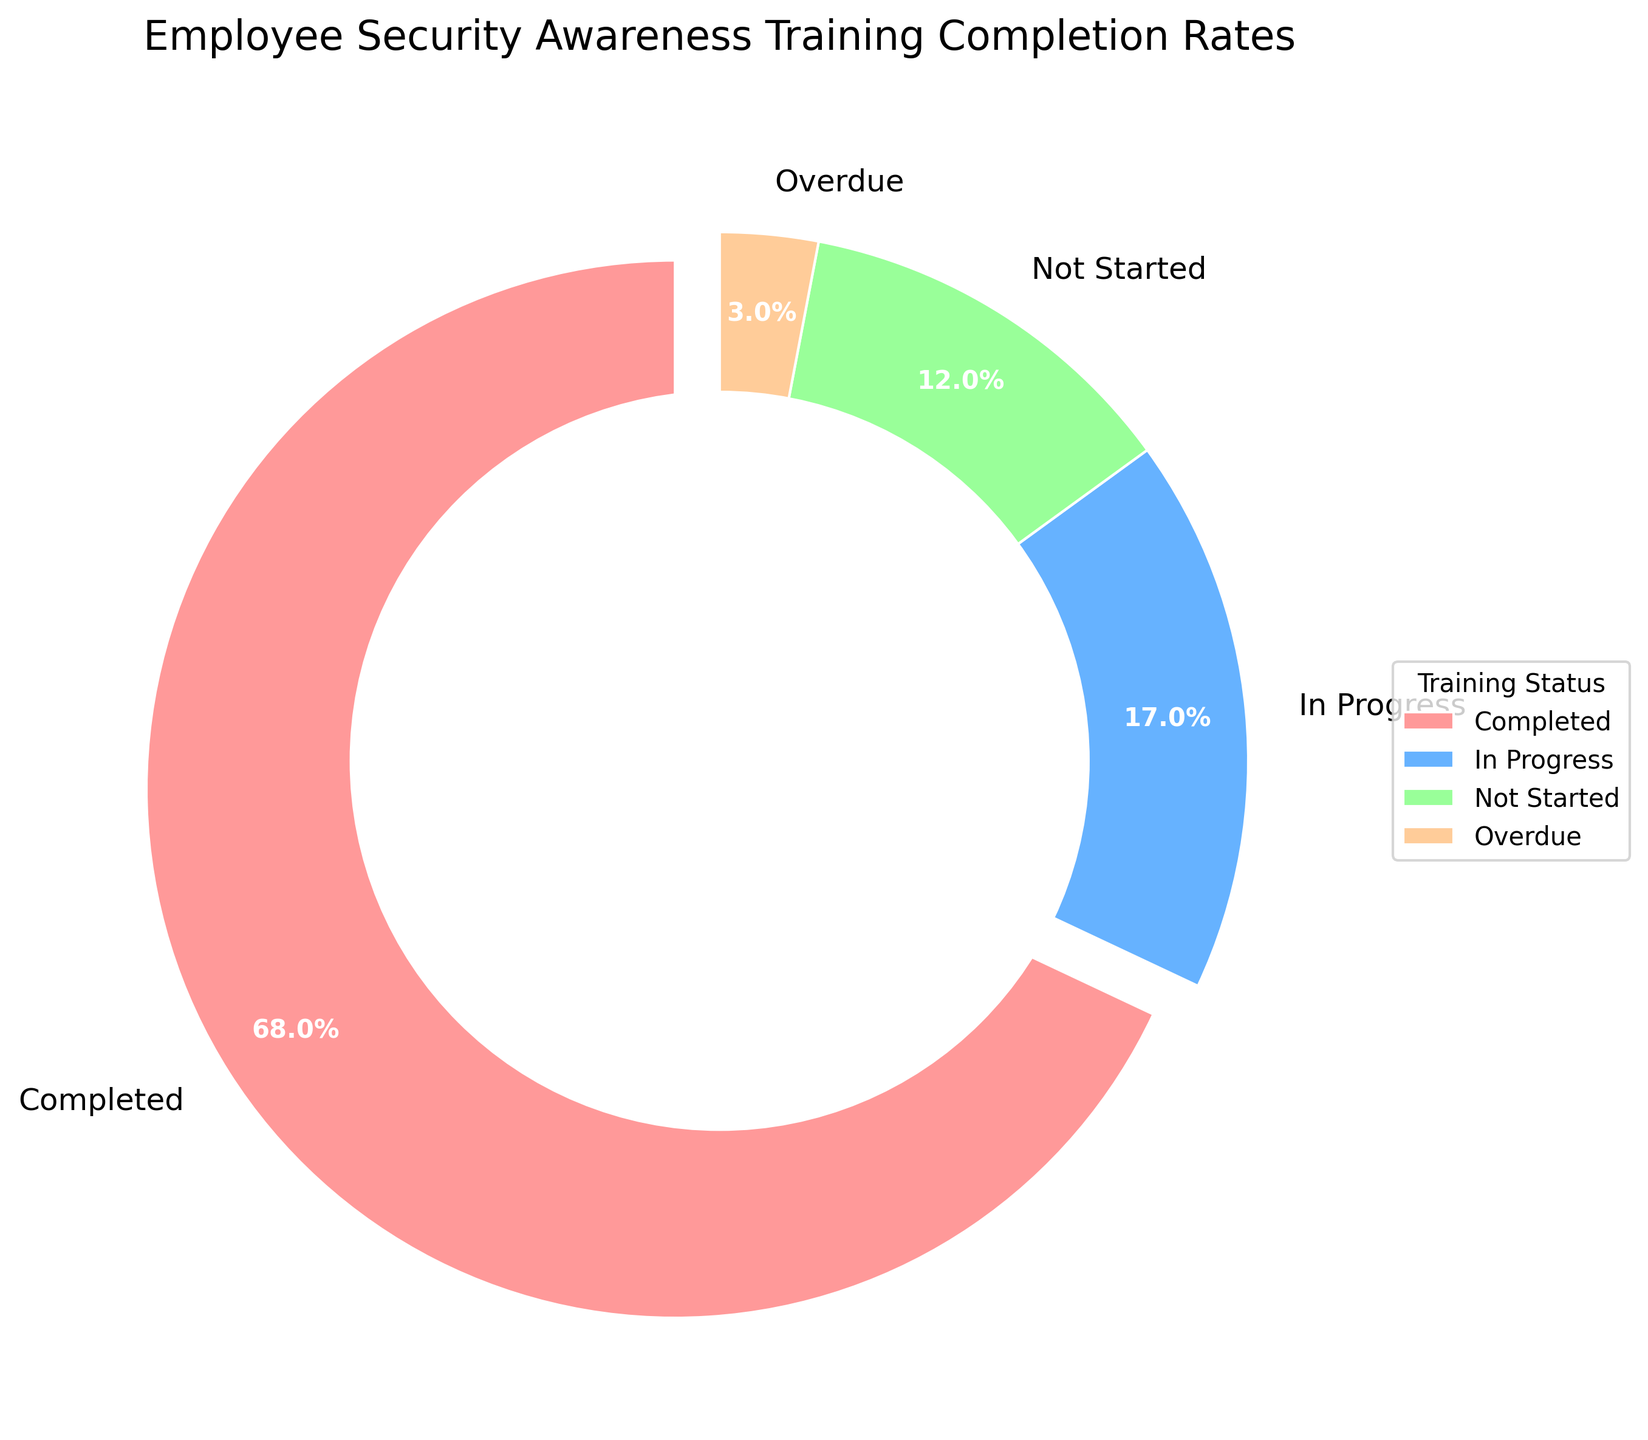What percentage of employees have completed the training? To find the percentage of employees who have completed the training, look at the "Completed" section of the pie chart. The chart indicates this percentage directly.
Answer: 68% Which training status has the smallest percentage? To determine the smallest percentage, visually compare the sizes of the slices in the pie chart. The slice labeled "Overdue" is the smallest.
Answer: Overdue What is the total percentage of employees who have either not started or are overdue in their training? Add the percentages for "Not Started" and "Overdue" together. That is 12% + 3% = 15%.
Answer: 15% Compare the percentage of employees who are "In Progress" with those who have "Not Started" the training. Compare the sizes of the slices labeled "In Progress" and "Not Started." The slice for "In Progress" is larger at 17%, while "Not Started" is 12%.
Answer: In Progress is larger What portion of the pie chart is represented by employees still involved in the training (both "In Progress" and "Not Started")? Add the percentages for "In Progress" and "Not Started". That is 17% + 12% = 29%.
Answer: 29% Which color represents the employees who have completed their training? Identify the color of the slice labeled "Completed" in the pie chart. The color is red.
Answer: Red How much larger is the percentage of "Completed" training compared to "In Progress"? Calculate the difference between the percentages of "Completed" and "In Progress." That is 68% - 17% = 51%.
Answer: 51% What is the percentage of incomplete training (combining "In Progress", "Not Started", and "Overdue")? Sum the percentages of "In Progress," "Not Started," and "Overdue." That is 17% + 12% + 3% = 32%.
Answer: 32% If we want at least 75% of employees to complete the training, how much should the "Completed" percentage increase? Calculate the difference needed to reach 75% from the current 68%. That is 75% - 68% = 7%.
Answer: 7% What is the visual difference between the "Completed" and "Not Started" sections of the chart? The "Completed" section is visually larger and is typically represented by a different color (red for "Completed"). The percentage for "Completed" (68%) is significantly higher than that for "Not Started" (12%), making their slices' sizes distinctly different.
Answer: Completed is much larger and red 